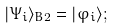<formula> <loc_0><loc_0><loc_500><loc_500>| \Psi _ { i } \rangle _ { B 2 } = | \varphi _ { i } \rangle ;</formula> 